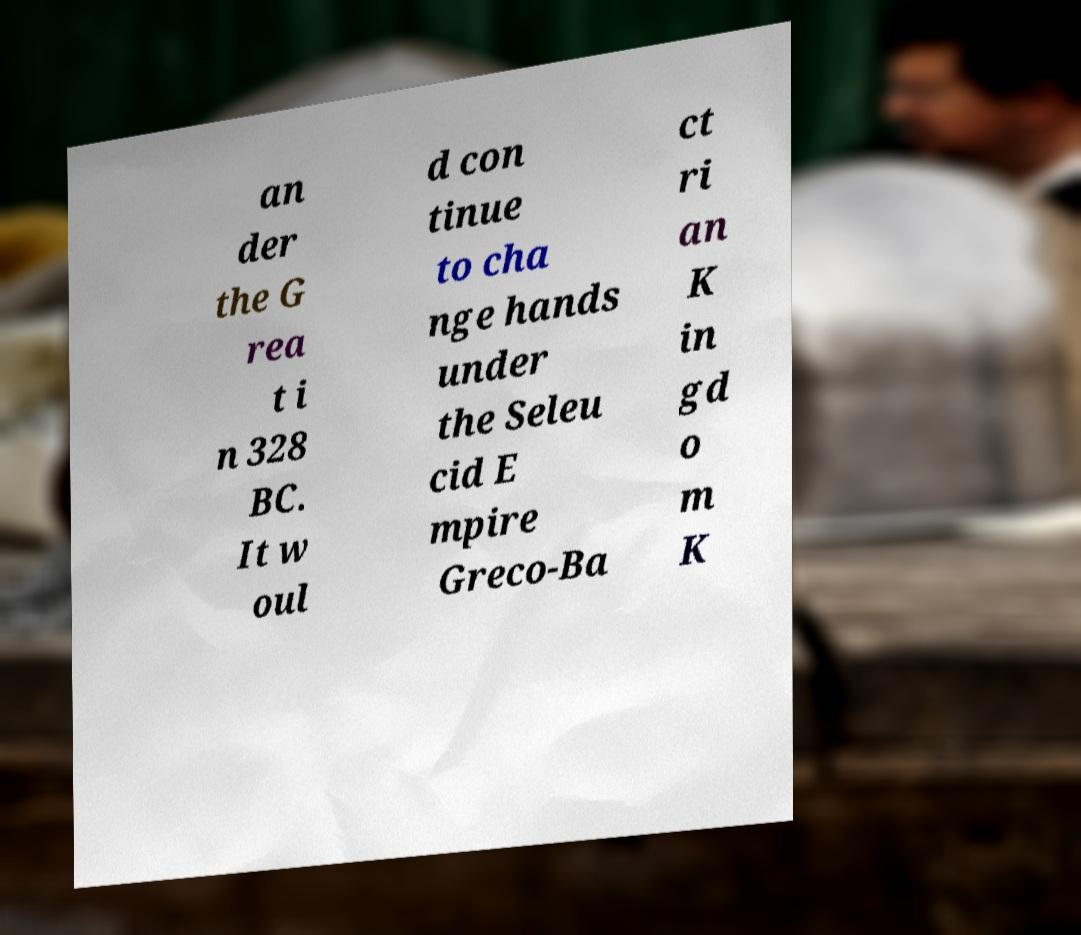There's text embedded in this image that I need extracted. Can you transcribe it verbatim? an der the G rea t i n 328 BC. It w oul d con tinue to cha nge hands under the Seleu cid E mpire Greco-Ba ct ri an K in gd o m K 